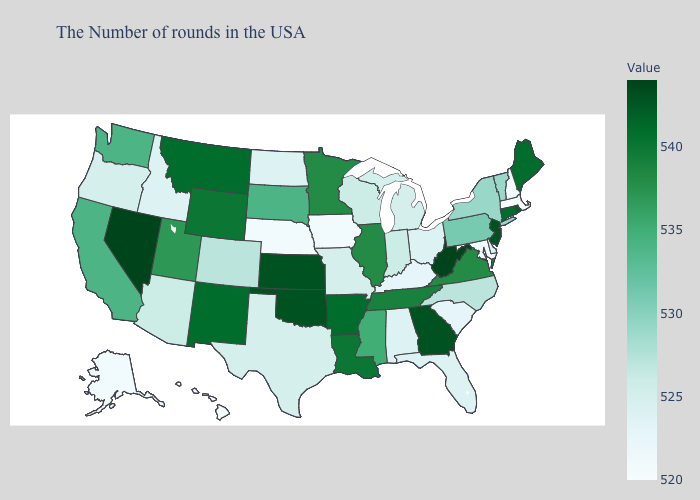Which states have the lowest value in the USA?
Be succinct. Massachusetts, Hawaii. Which states hav the highest value in the Northeast?
Give a very brief answer. New Jersey. Does Nevada have the highest value in the USA?
Write a very short answer. Yes. Among the states that border Virginia , does Maryland have the lowest value?
Be succinct. Yes. Does the map have missing data?
Answer briefly. No. Does Connecticut have the lowest value in the USA?
Be succinct. No. Among the states that border Vermont , does New Hampshire have the lowest value?
Give a very brief answer. No. Which states have the lowest value in the Northeast?
Answer briefly. Massachusetts. 